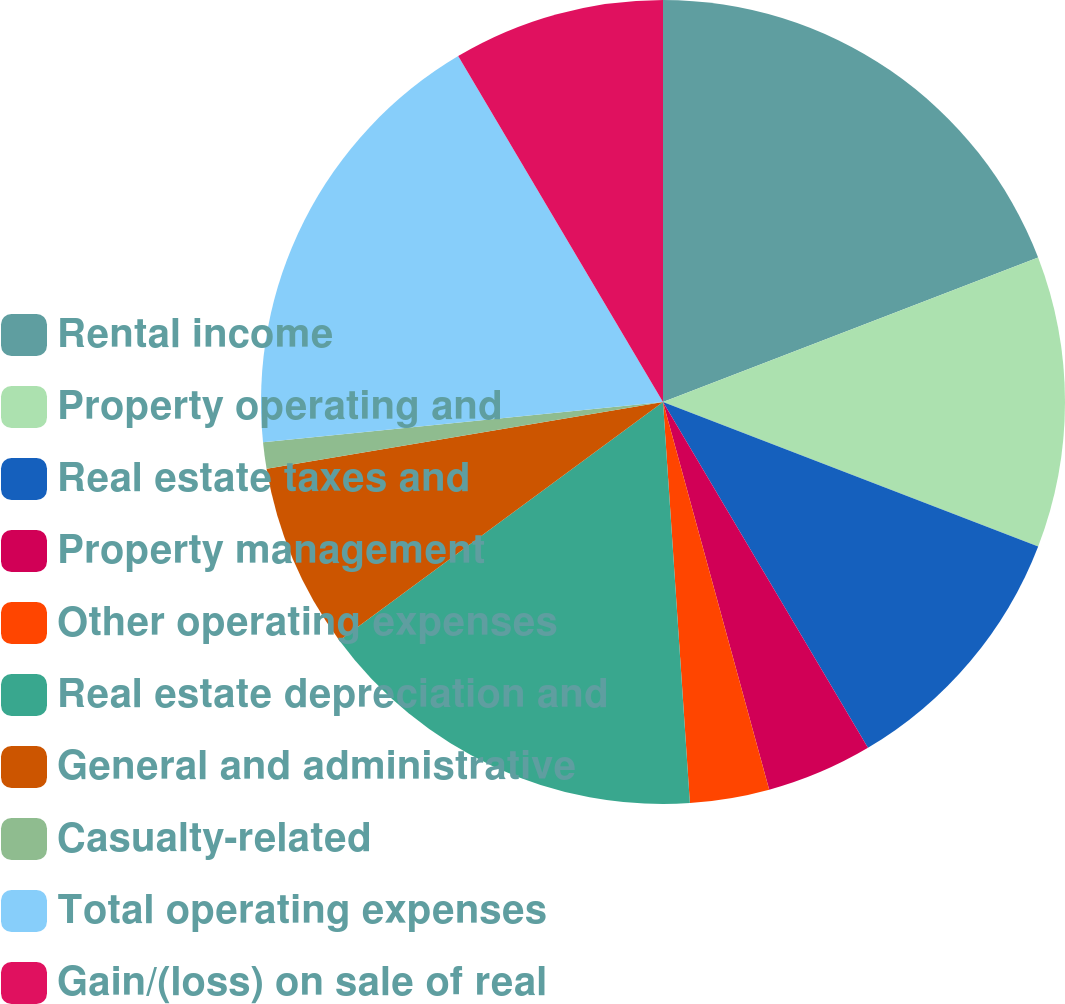<chart> <loc_0><loc_0><loc_500><loc_500><pie_chart><fcel>Rental income<fcel>Property operating and<fcel>Real estate taxes and<fcel>Property management<fcel>Other operating expenses<fcel>Real estate depreciation and<fcel>General and administrative<fcel>Casualty-related<fcel>Total operating expenses<fcel>Gain/(loss) on sale of real<nl><fcel>19.15%<fcel>11.7%<fcel>10.64%<fcel>4.26%<fcel>3.19%<fcel>15.96%<fcel>7.45%<fcel>1.06%<fcel>18.09%<fcel>8.51%<nl></chart> 